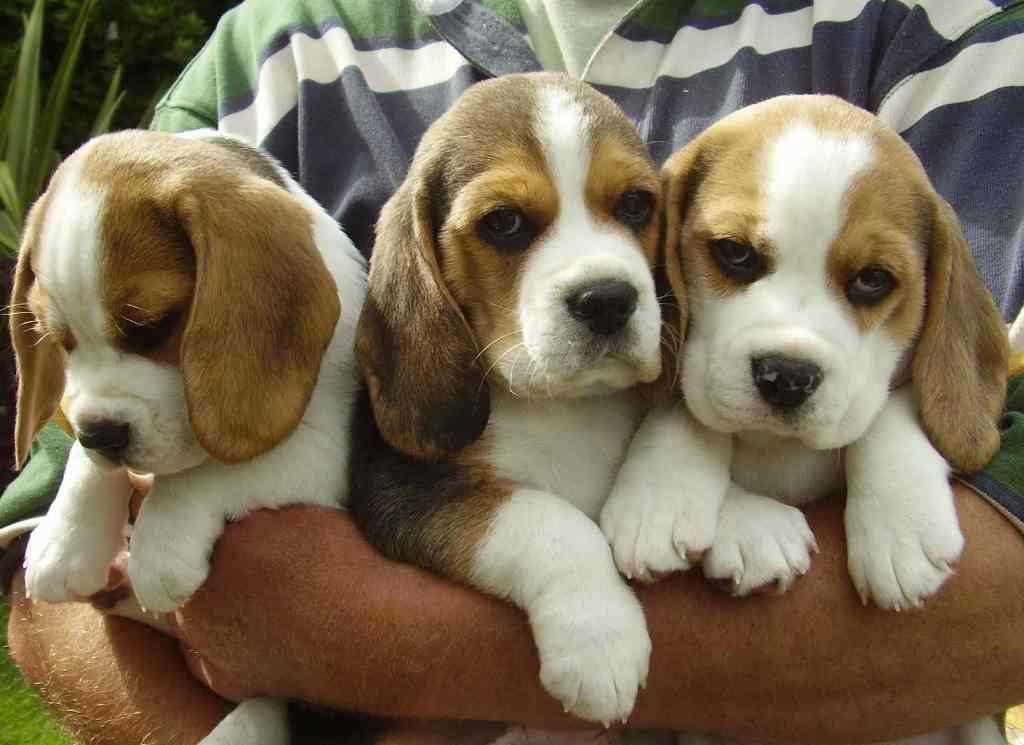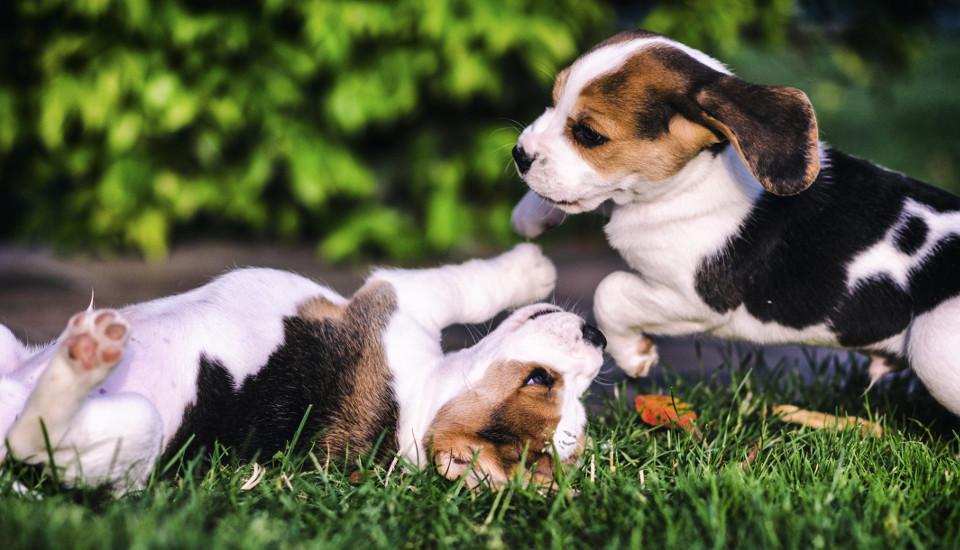The first image is the image on the left, the second image is the image on the right. For the images shown, is this caption "There are equal amount of dogs in the left image as the right." true? Answer yes or no. No. The first image is the image on the left, the second image is the image on the right. Evaluate the accuracy of this statement regarding the images: "An equal number of puppies are shown in each image at an outdoor location, one of them with its front paws in mid- air.". Is it true? Answer yes or no. No. 